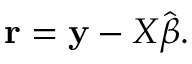Convert formula to latex. <formula><loc_0><loc_0><loc_500><loc_500>r = y - X { \hat { \beta } } .</formula> 